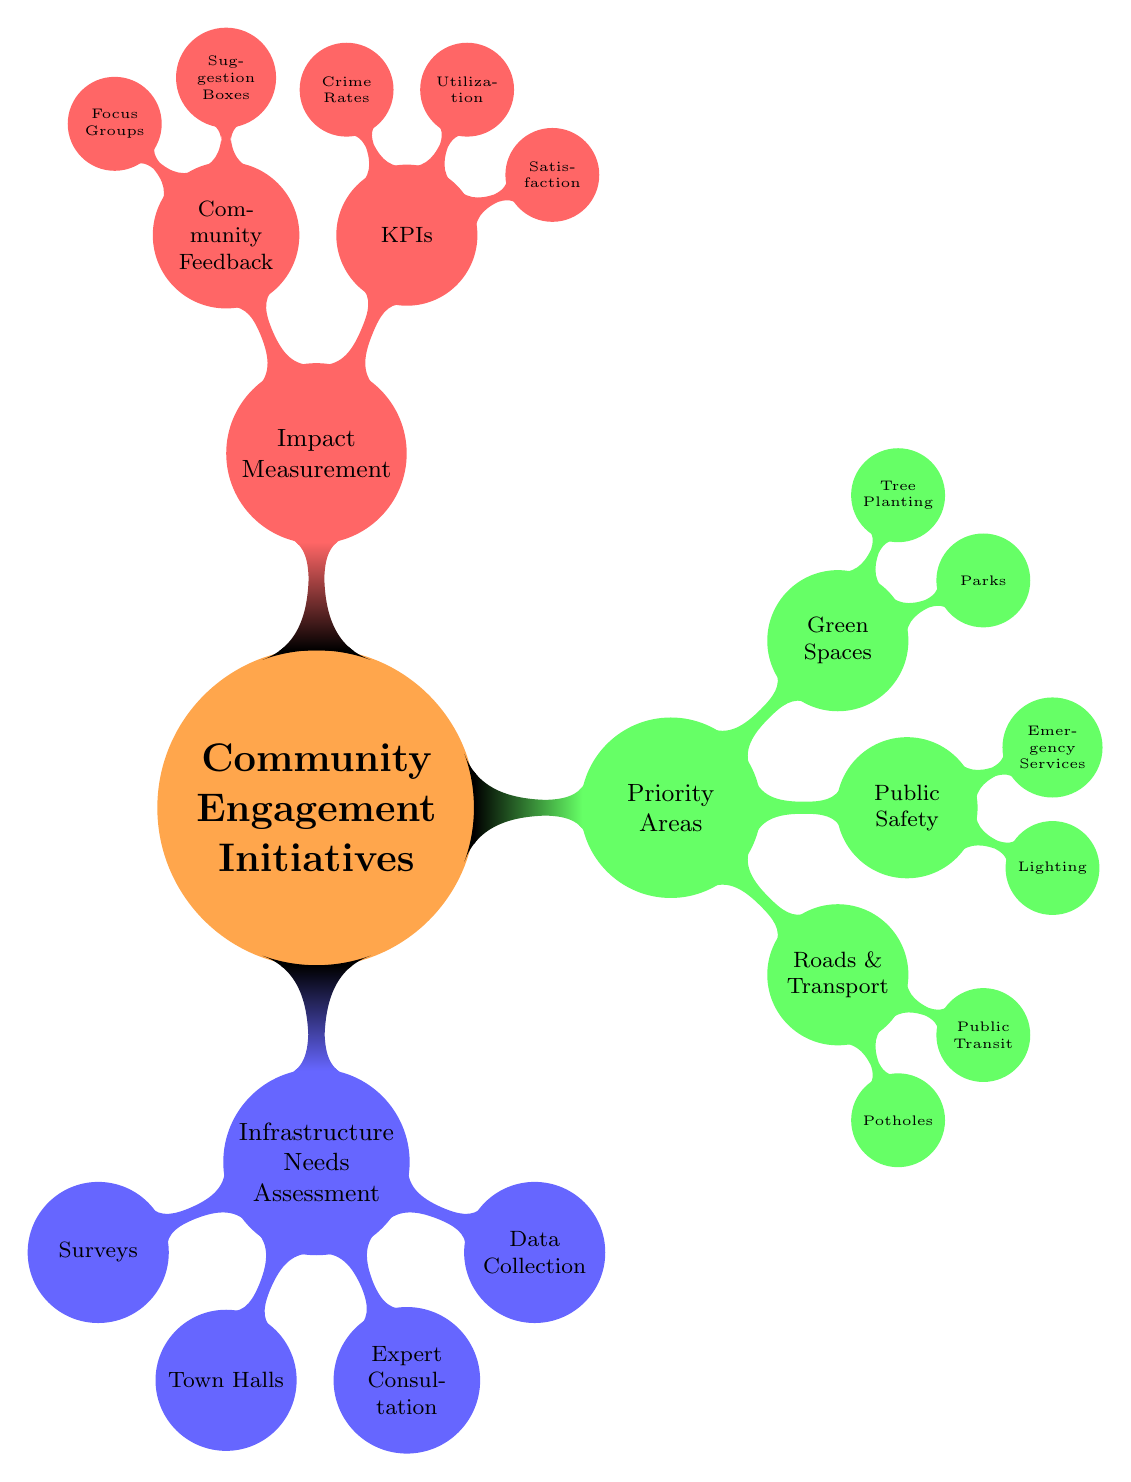What are the main categories of community engagement initiatives? The main categories are displayed as top-level nodes in the mind map and include Infrastructure Needs Assessment, Priority Areas, and Impact Measurement.
Answer: Infrastructure Needs Assessment, Priority Areas, Impact Measurement How many priority areas are identified in the diagram? The diagram shows three main priority areas within the Priority Areas node: Roads and Transportation, Public Safety, and Green Spaces.
Answer: 3 Which method is suggested for gathering community input? The diagram indicates several methods for gathering community input under the Infrastructure Needs Assessment category, including Surveys, Town Halls, and Expert Consultations.
Answer: Surveys, Town Halls, Expert Consultation What is indicated as a key performance indicator for measuring impact? One key performance indicator under the Impact Measurement category is Resident Satisfaction, which refers to assessing resident feedback post-implementation.
Answer: Resident Satisfaction Which specific area is prioritized for public safety improvements? Under the Priority Areas node, Public Safety includes two specific improvements: Street Lighting and Emergency Services, indicating high-priority infrastructure needs for community safety.
Answer: Street Lighting, Emergency Services How is the concept of community feedback represented in the diagram? Community feedback is represented under the Impact Measurement category, with specific methods such as Suggestion Boxes and Focus Groups listed as ways to gather community opinions and suggestions.
Answer: Suggestion Boxes, Focus Groups What are two specific areas of focus regarding Roads and Transportation? The Roads and Transportation category highlights Pothole Repairs and Public Transit Upgrades, indicating urgent infrastructure needs in transportation for the community.
Answer: Pothole Repairs, Public Transit Upgrades How are the initiatives organized within the mind map? The initiatives are organized hierarchically, with main themes branching into more specific aspects and methods, showing a clear structure of community engagement initiatives.
Answer: Hierarchically 